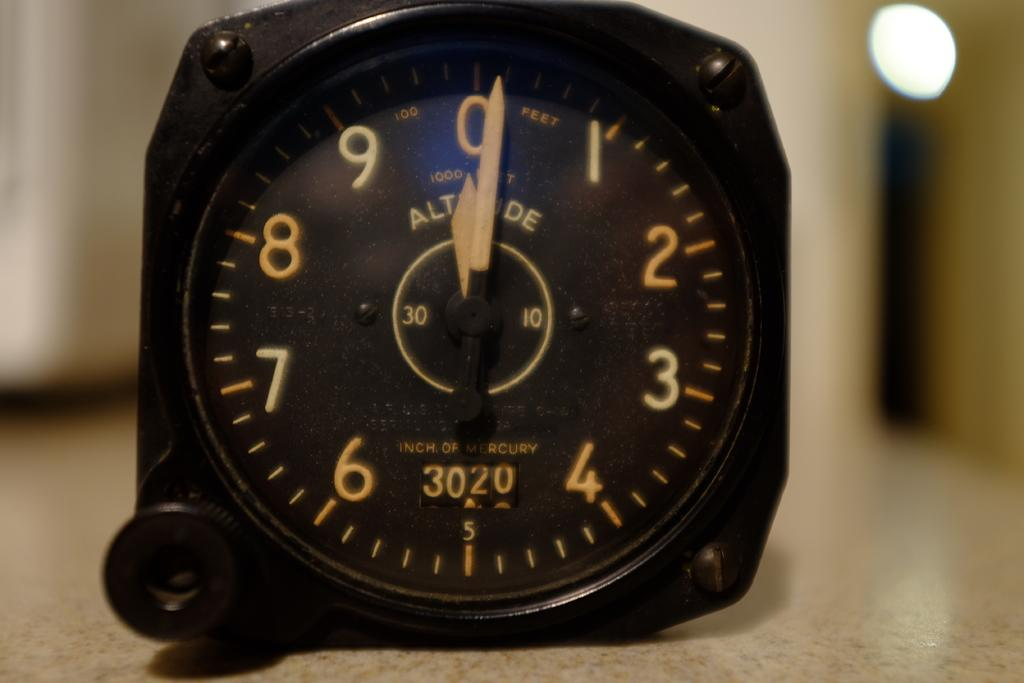<image>
Render a clear and concise summary of the photo. Face of a black wristwatch that says the numbers 3020 on it. 